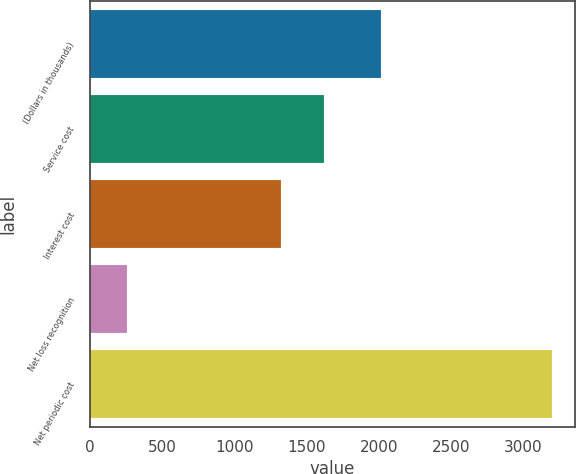Convert chart to OTSL. <chart><loc_0><loc_0><loc_500><loc_500><bar_chart><fcel>(Dollars in thousands)<fcel>Service cost<fcel>Interest cost<fcel>Net loss recognition<fcel>Net periodic cost<nl><fcel>2014<fcel>1619<fcel>1320<fcel>257<fcel>3196<nl></chart> 